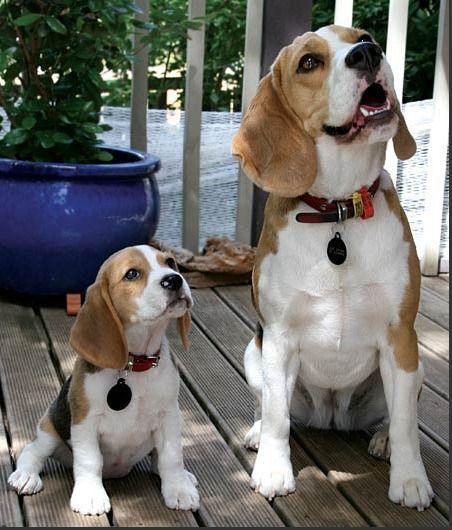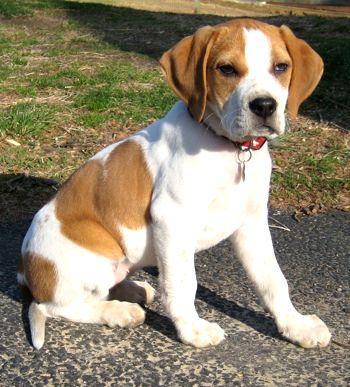The first image is the image on the left, the second image is the image on the right. Considering the images on both sides, is "An image shows beagle dogs behind a horizontal wood plank rail." valid? Answer yes or no. No. 